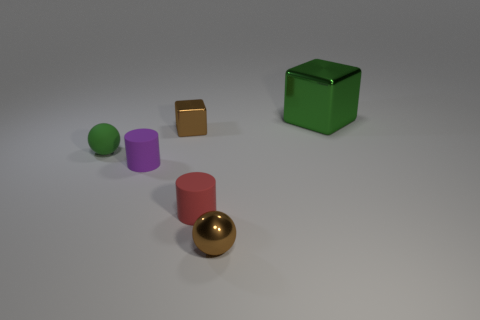Are there any other things that are the same size as the green cube?
Give a very brief answer. No. How many red rubber cylinders are there?
Offer a very short reply. 1. Is the sphere that is in front of the red rubber thing made of the same material as the tiny ball that is behind the tiny brown metal ball?
Provide a succinct answer. No. There is a purple cylinder that is the same material as the small green sphere; what is its size?
Make the answer very short. Small. There is a green thing behind the green matte object; what shape is it?
Keep it short and to the point. Cube. Is the color of the sphere that is on the left side of the small metallic block the same as the small cube on the left side of the big green shiny block?
Ensure brevity in your answer.  No. There is a matte ball that is the same color as the large metallic object; what size is it?
Offer a very short reply. Small. Are there any big purple metallic things?
Your response must be concise. No. What shape is the tiny brown metallic thing left of the sphere that is in front of the green object that is on the left side of the big green cube?
Ensure brevity in your answer.  Cube. There is a tiny green matte sphere; what number of small green spheres are in front of it?
Your response must be concise. 0. 